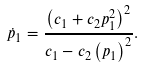Convert formula to latex. <formula><loc_0><loc_0><loc_500><loc_500>\dot { p } _ { 1 } = \frac { \left ( c _ { 1 } + c _ { 2 } p _ { 1 } ^ { 2 } \right ) ^ { 2 } } { c _ { 1 } - c _ { 2 } \left ( p _ { 1 } \right ) ^ { 2 } } .</formula> 